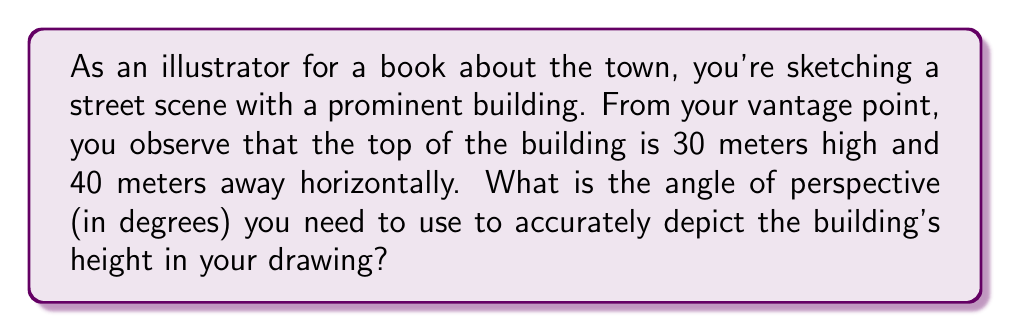What is the answer to this math problem? To find the angle of perspective, we need to use trigonometry. Let's approach this step-by-step:

1) We can visualize this scenario as a right triangle, where:
   - The building's height is the opposite side (30 meters)
   - The horizontal distance is the adjacent side (40 meters)
   - The angle we're looking for is the one between the ground and our line of sight

2) In this case, we need to use the tangent function, as it relates the opposite and adjacent sides:

   $$ \tan(\theta) = \frac{\text{opposite}}{\text{adjacent}} $$

3) Substituting our values:

   $$ \tan(\theta) = \frac{30}{40} = \frac{3}{4} = 0.75 $$

4) To find the angle $\theta$, we need to use the inverse tangent (arctan or $\tan^{-1}$):

   $$ \theta = \tan^{-1}(0.75) $$

5) Using a calculator or mathematical tables, we can determine that:

   $$ \theta \approx 36.87^\circ $$

6) Rounding to two decimal places:

   $$ \theta \approx 36.87^\circ $$

This is the angle of perspective you should use in your illustration to accurately depict the building's height.
Answer: $36.87^\circ$ 